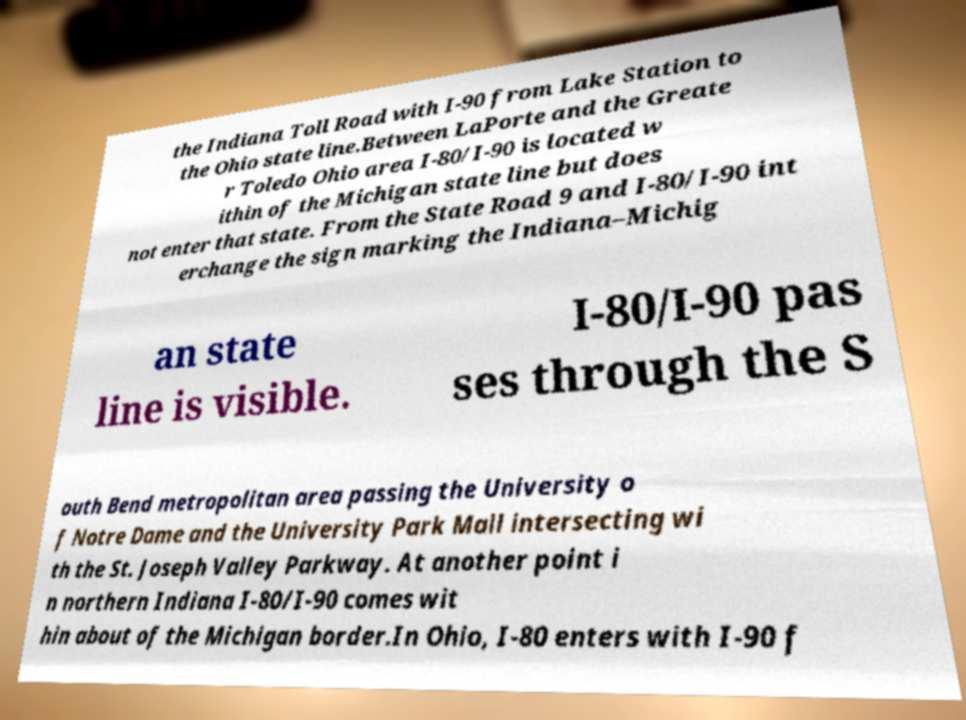What messages or text are displayed in this image? I need them in a readable, typed format. the Indiana Toll Road with I-90 from Lake Station to the Ohio state line.Between LaPorte and the Greate r Toledo Ohio area I-80/I-90 is located w ithin of the Michigan state line but does not enter that state. From the State Road 9 and I-80/I-90 int erchange the sign marking the Indiana–Michig an state line is visible. I-80/I-90 pas ses through the S outh Bend metropolitan area passing the University o f Notre Dame and the University Park Mall intersecting wi th the St. Joseph Valley Parkway. At another point i n northern Indiana I-80/I-90 comes wit hin about of the Michigan border.In Ohio, I-80 enters with I-90 f 